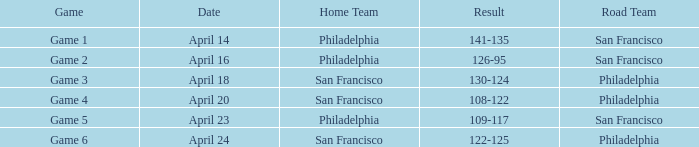Can you parse all the data within this table? {'header': ['Game', 'Date', 'Home Team', 'Result', 'Road Team'], 'rows': [['Game 1', 'April 14', 'Philadelphia', '141-135', 'San Francisco'], ['Game 2', 'April 16', 'Philadelphia', '126-95', 'San Francisco'], ['Game 3', 'April 18', 'San Francisco', '130-124', 'Philadelphia'], ['Game 4', 'April 20', 'San Francisco', '108-122', 'Philadelphia'], ['Game 5', 'April 23', 'Philadelphia', '109-117', 'San Francisco'], ['Game 6', 'April 24', 'San Francisco', '122-125', 'Philadelphia']]} Which game had Philadelphia as its home team and was played on April 23? Game 5. 